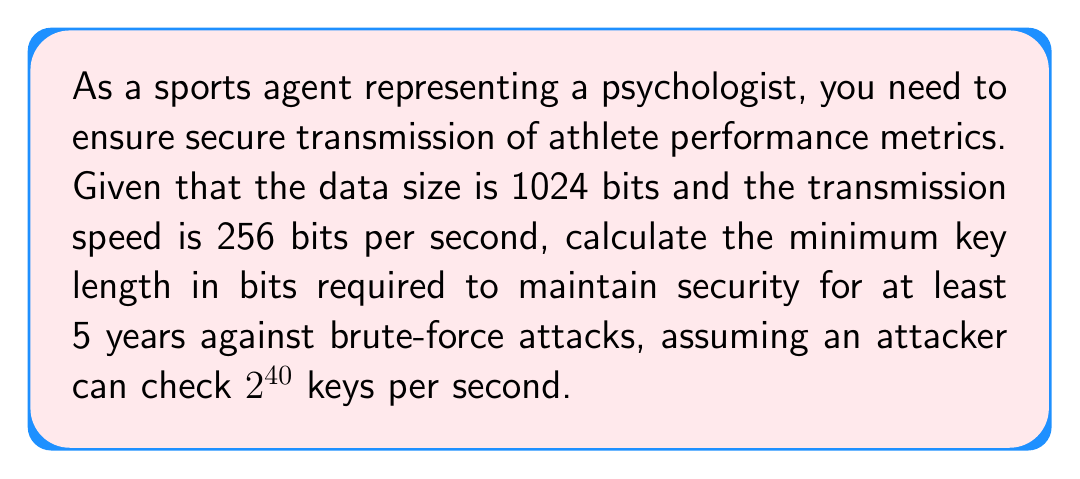Provide a solution to this math problem. 1. First, calculate the time required for one transmission:
   $$\text{Transmission time} = \frac{\text{Data size}}{\text{Transmission speed}} = \frac{1024 \text{ bits}}{256 \text{ bits/s}} = 4 \text{ seconds}$$

2. Calculate the number of transmissions in 5 years:
   $$\text{Number of transmissions} = \frac{5 \text{ years} \times 365 \text{ days/year} \times 24 \text{ hours/day} \times 3600 \text{ s/hour}}{4 \text{ s/transmission}} = 39,420,000$$

3. To maintain security, the key space should be larger than the number of keys an attacker can check in 5 years:
   $$\text{Keys attacker can check} = 2^{40} \text{ keys/s} \times 5 \text{ years} \times 365 \text{ days/year} \times 24 \text{ hours/day} \times 3600 \text{ s/hour} = 2^{55.95}$$

4. The key space should be larger than both the number of transmissions and the number of keys an attacker can check:
   $$\text{Key space} > \max(39,420,000, 2^{55.95}) = 2^{55.95}$$

5. To determine the minimum key length, we need to find the smallest integer $n$ such that $2^n > 2^{55.95}$:
   $$n > 55.95$$

6. The smallest integer satisfying this condition is 56.

Therefore, the minimum key length required is 56 bits.
Answer: 56 bits 